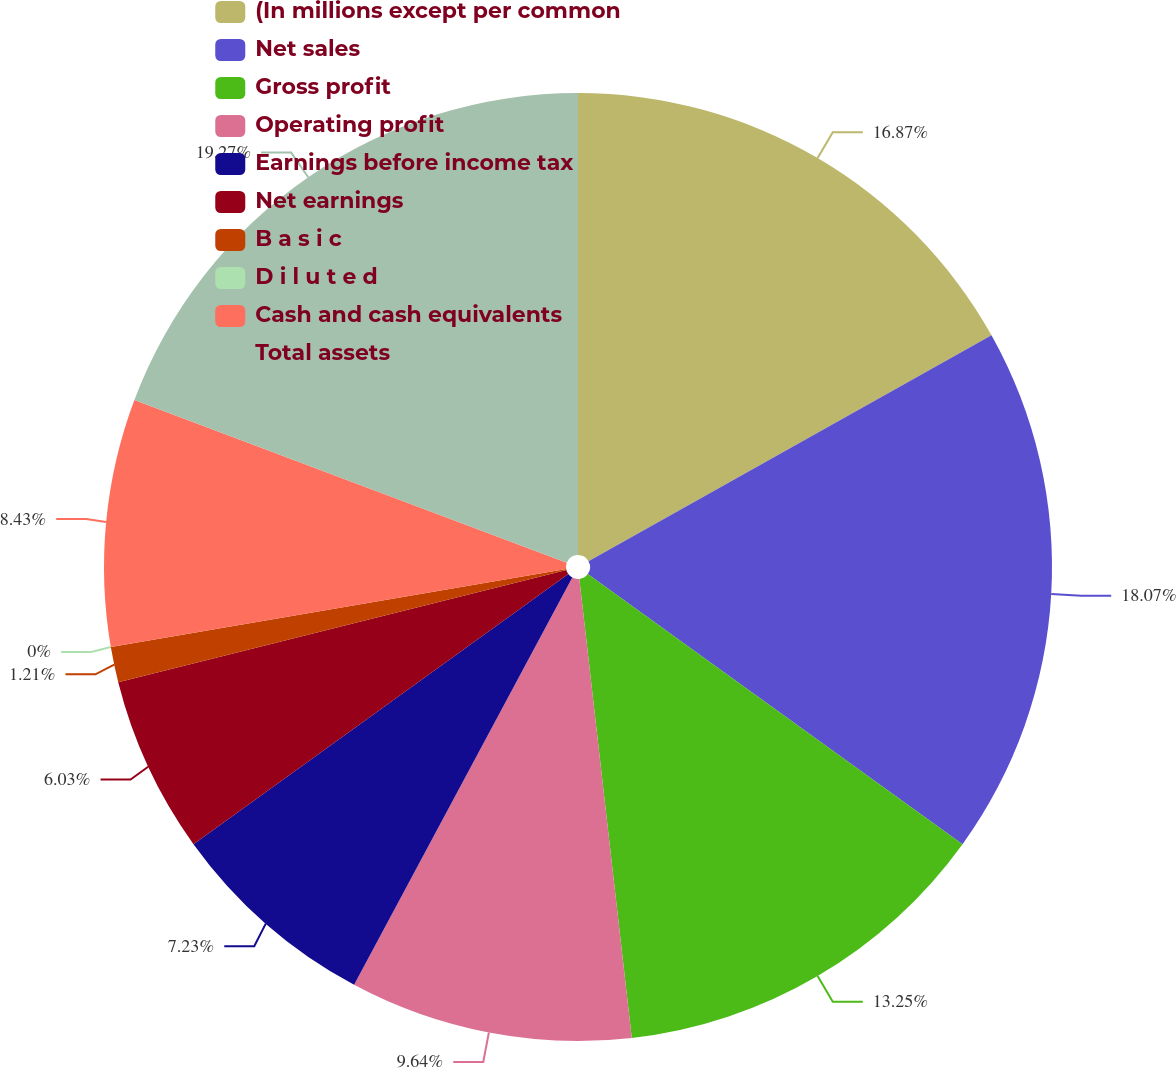Convert chart to OTSL. <chart><loc_0><loc_0><loc_500><loc_500><pie_chart><fcel>(In millions except per common<fcel>Net sales<fcel>Gross profit<fcel>Operating profit<fcel>Earnings before income tax<fcel>Net earnings<fcel>B a s i c<fcel>D i l u t e d<fcel>Cash and cash equivalents<fcel>Total assets<nl><fcel>16.87%<fcel>18.07%<fcel>13.25%<fcel>9.64%<fcel>7.23%<fcel>6.03%<fcel>1.21%<fcel>0.0%<fcel>8.43%<fcel>19.27%<nl></chart> 